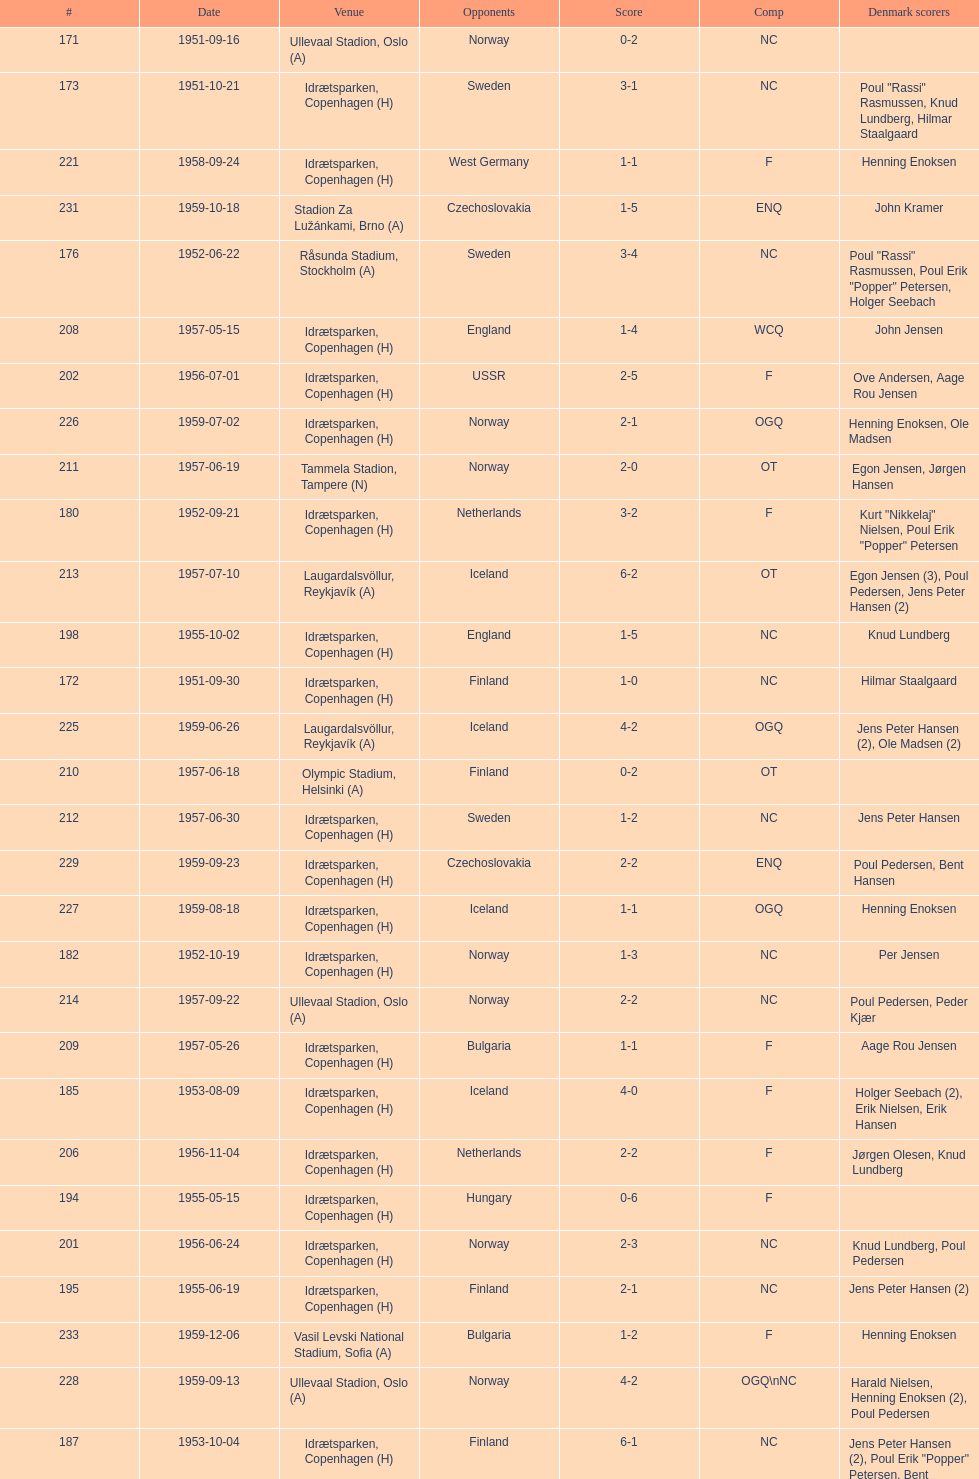Who did they play in the game listed directly above july 25, 1952? Poland. 